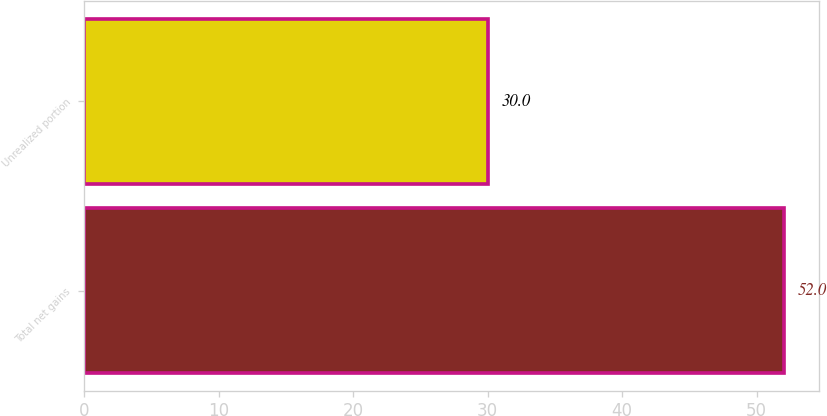Convert chart. <chart><loc_0><loc_0><loc_500><loc_500><bar_chart><fcel>Total net gains<fcel>Unrealized portion<nl><fcel>52<fcel>30<nl></chart> 